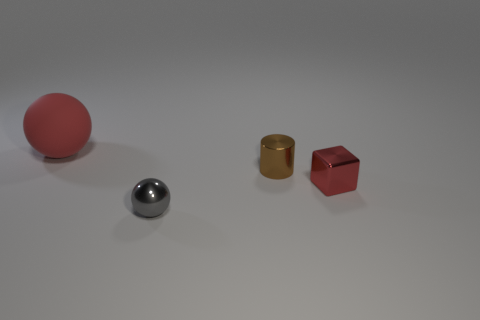Add 1 small shiny blocks. How many objects exist? 5 Subtract all red spheres. Subtract all red rubber balls. How many objects are left? 2 Add 4 brown objects. How many brown objects are left? 5 Add 2 gray shiny things. How many gray shiny things exist? 3 Subtract 0 purple spheres. How many objects are left? 4 Subtract all cylinders. How many objects are left? 3 